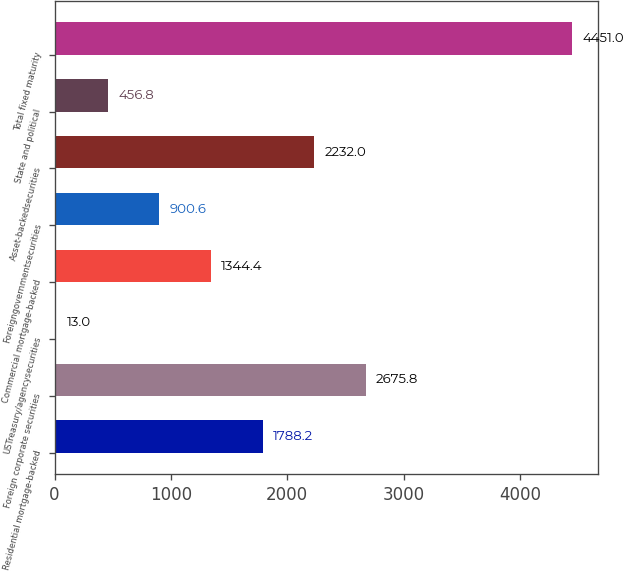Convert chart. <chart><loc_0><loc_0><loc_500><loc_500><bar_chart><fcel>Residential mortgage-backed<fcel>Foreign corporate securities<fcel>USTreasury/agencysecurities<fcel>Commercial mortgage-backed<fcel>Foreigngovernmentsecurities<fcel>Asset-backedsecurities<fcel>State and political<fcel>Total fixed maturity<nl><fcel>1788.2<fcel>2675.8<fcel>13<fcel>1344.4<fcel>900.6<fcel>2232<fcel>456.8<fcel>4451<nl></chart> 